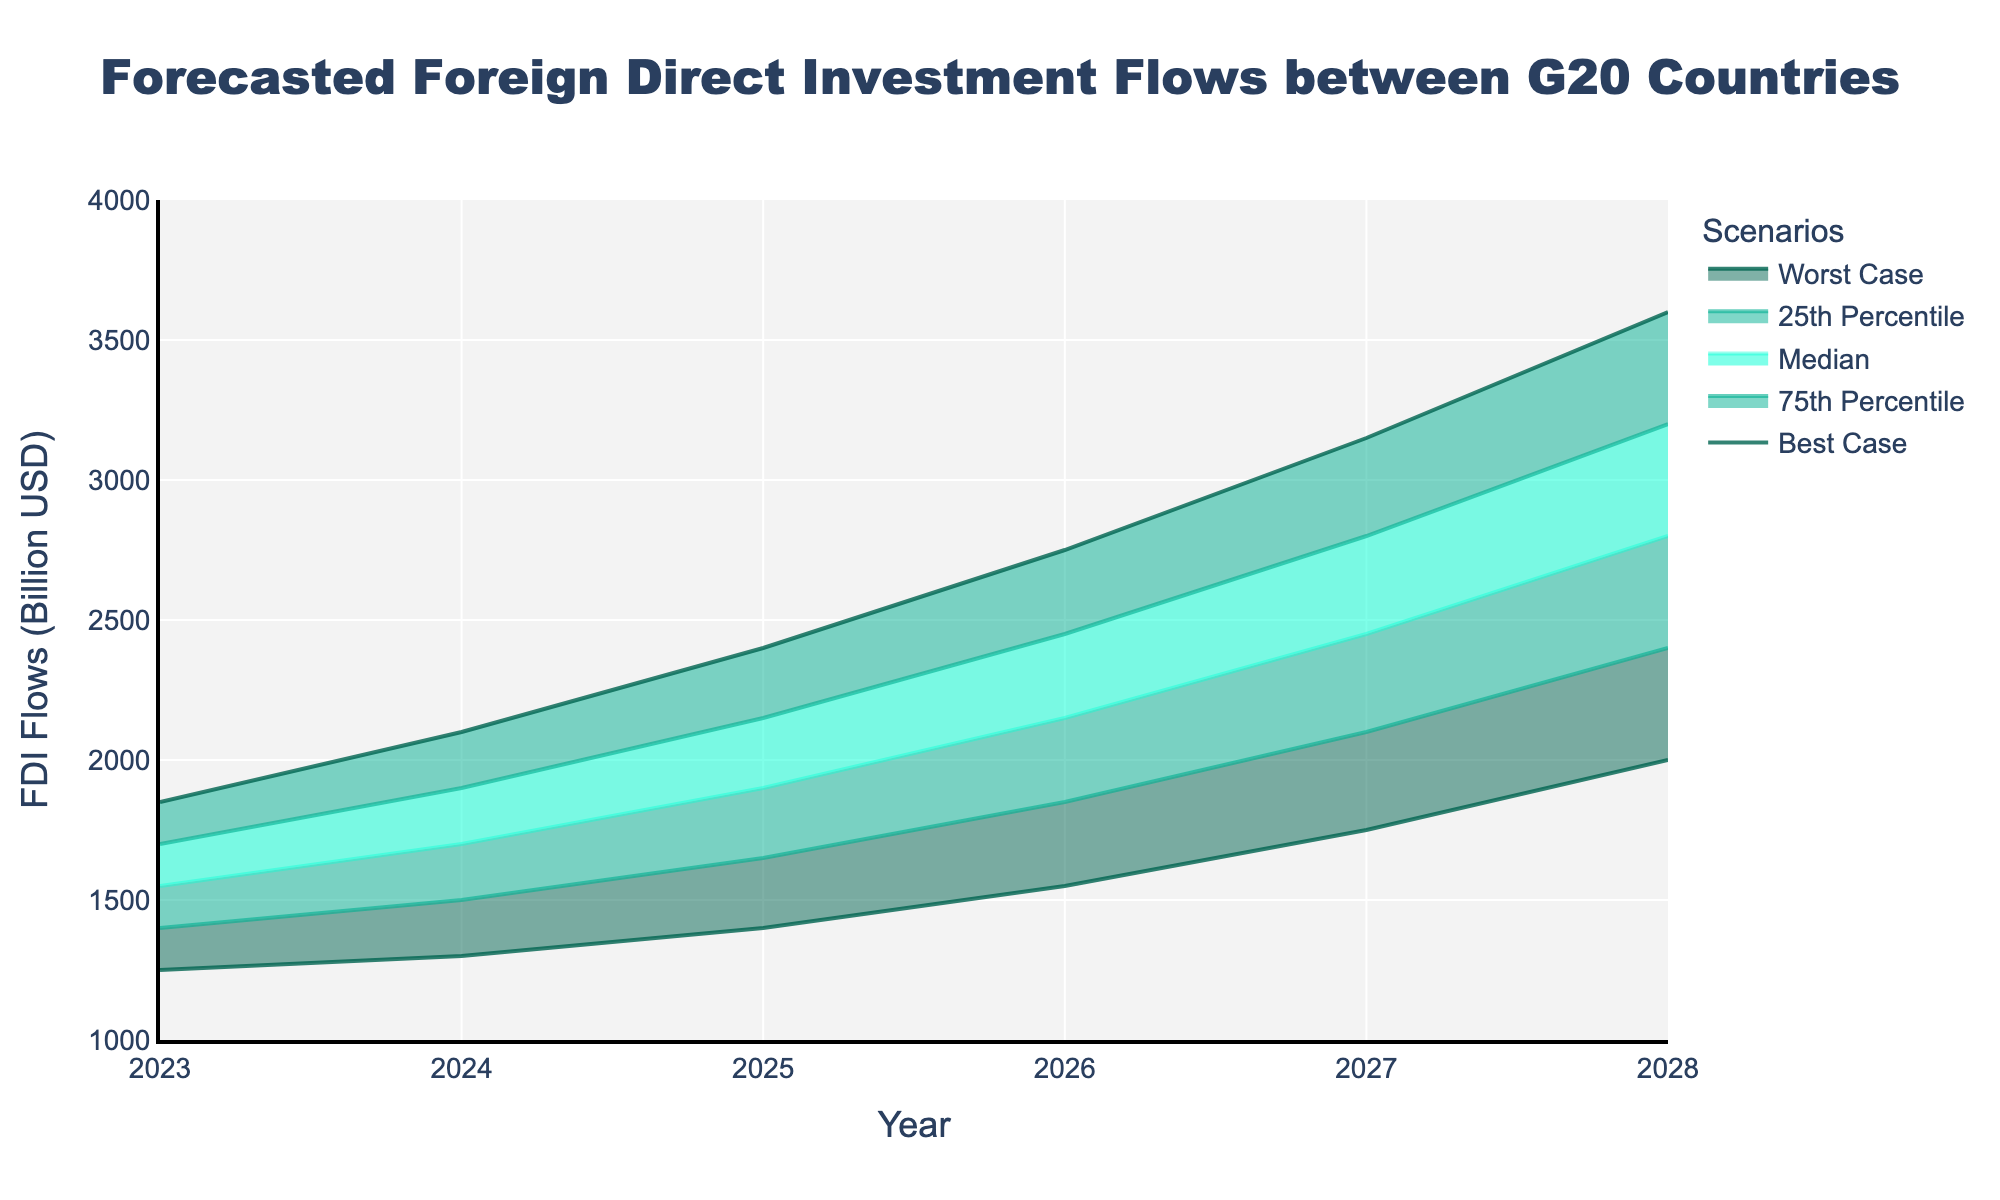What is the worst-case forecast for FDI flows in 2028? To find the worst-case forecast, look for the value in the Worst Case column for the year 2028.
Answer: 2000 What is the title of the chart? The title is typically located at the top of the chart.
Answer: Forecasted Foreign Direct Investment Flows between G20 Countries How does the median FDI flow change from 2024 to 2025? To determine the change, subtract the median value for 2024 from the median value for 2025. 1900 - 1700 = 200
Answer: Increases by 200 Which year shows the largest gap between the best-case and worst-case scenarios? Calculate the difference between the best-case and worst-case for each year, then find the maximum difference. 2750 - 1250 (2023) = 600 2100 - 1300 (2024) = 800 2400 - 1400 (2025) = 1000 2750 - 1550 (2026) = 1200 3150 - 1750 (2027) = 1400 3600 - 2000 (2028) = 1600
Answer: 2028 What is the 25th percentile value for 2025? Look up the value in the 25th Percentile column for the year 2025.
Answer: 1650 By how much is the best-case scenario in 2027 higher than the median scenario in 2024? Subtract the median value for 2024 from the best-case value for 2027. 3150 - 1700 = 1450
Answer: 1450 Which scenario in 2026 is closest to 2000? Compare each scenario's value in 2026 to 2000 and find the closest one. Best Case: 2750 75th Percentile: 2450 Median: 2150 25th Percentile: 1850 Worst Case: 1550 2150 is closest to 2000
Answer: Median Between which two consecutive years does the 75th percentile show the greatest increase? Calculate the increase for the 75th percentile between each consecutive year and find the maximum difference. 1900 - 1700 (2024 - 2023) = 200 2150 - 1900 (2025 - 2024) = 250 2450 - 2150 (2026 - 2025) = 300 2800 - 2450 (2027 - 2026) = 350 3200 - 2800 (2028 - 2027) = 400
Answer: Between 2027 and 2028 